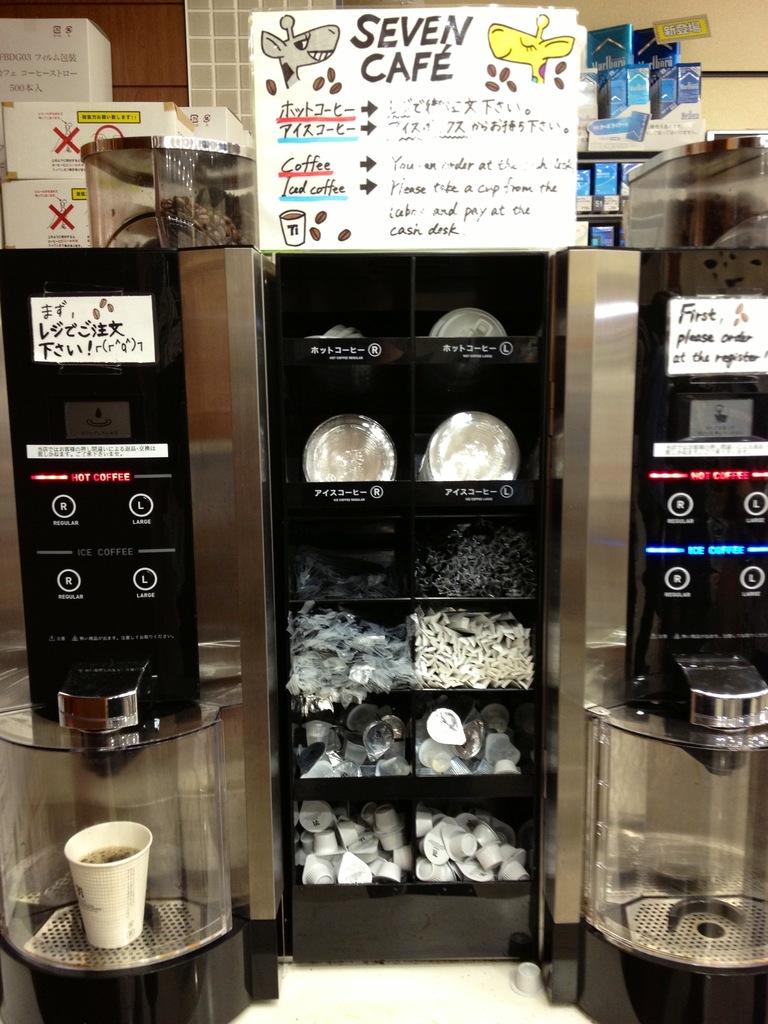What is the name of the cafe?
Your answer should be compact. Seven. 